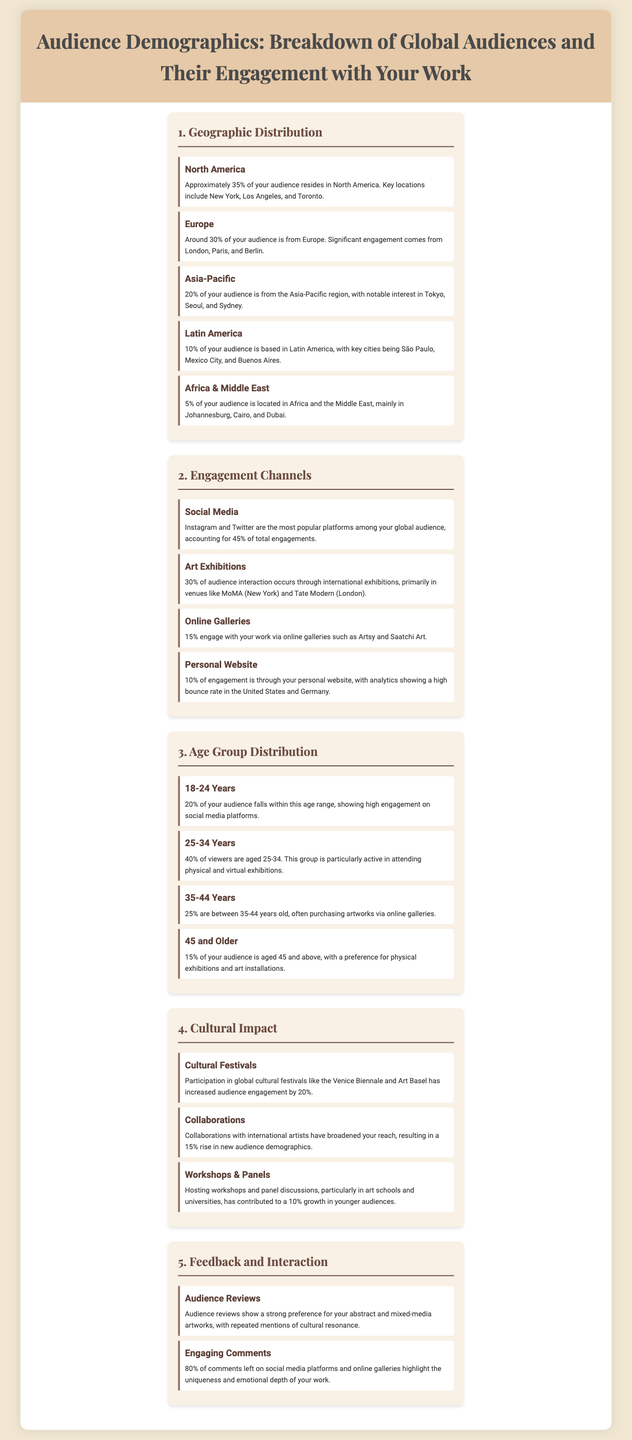what percentage of your audience resides in North America? The document states that approximately 35% of the audience is from North America.
Answer: 35% which social media platforms account for the highest engagement? The document specifies that Instagram and Twitter are the most popular platforms among the global audience.
Answer: Instagram and Twitter what age group has the largest percentage of your audience? The document indicates that 40% of viewers are aged 25-34, making it the largest age group.
Answer: 25-34 Years how many key cities are mentioned in the Latin America section? The Latin America section lists three key cities: São Paulo, Mexico City, and Buenos Aires.
Answer: Three by what percentage did audience engagement increase due to participation in cultural festivals? According to the document, audience engagement increased by 20% due to participation in global cultural festivals.
Answer: 20% what is the primary venue for international exhibitions mentioned in the document? The document mentions MoMA in New York and Tate Modern in London as primary venues for international exhibitions.
Answer: MoMA and Tate Modern 